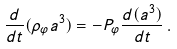Convert formula to latex. <formula><loc_0><loc_0><loc_500><loc_500>\frac { d } { d t } ( \rho _ { \varphi } a ^ { 3 } ) = - P _ { \varphi } \frac { d ( a ^ { 3 } ) } { d t } \, .</formula> 